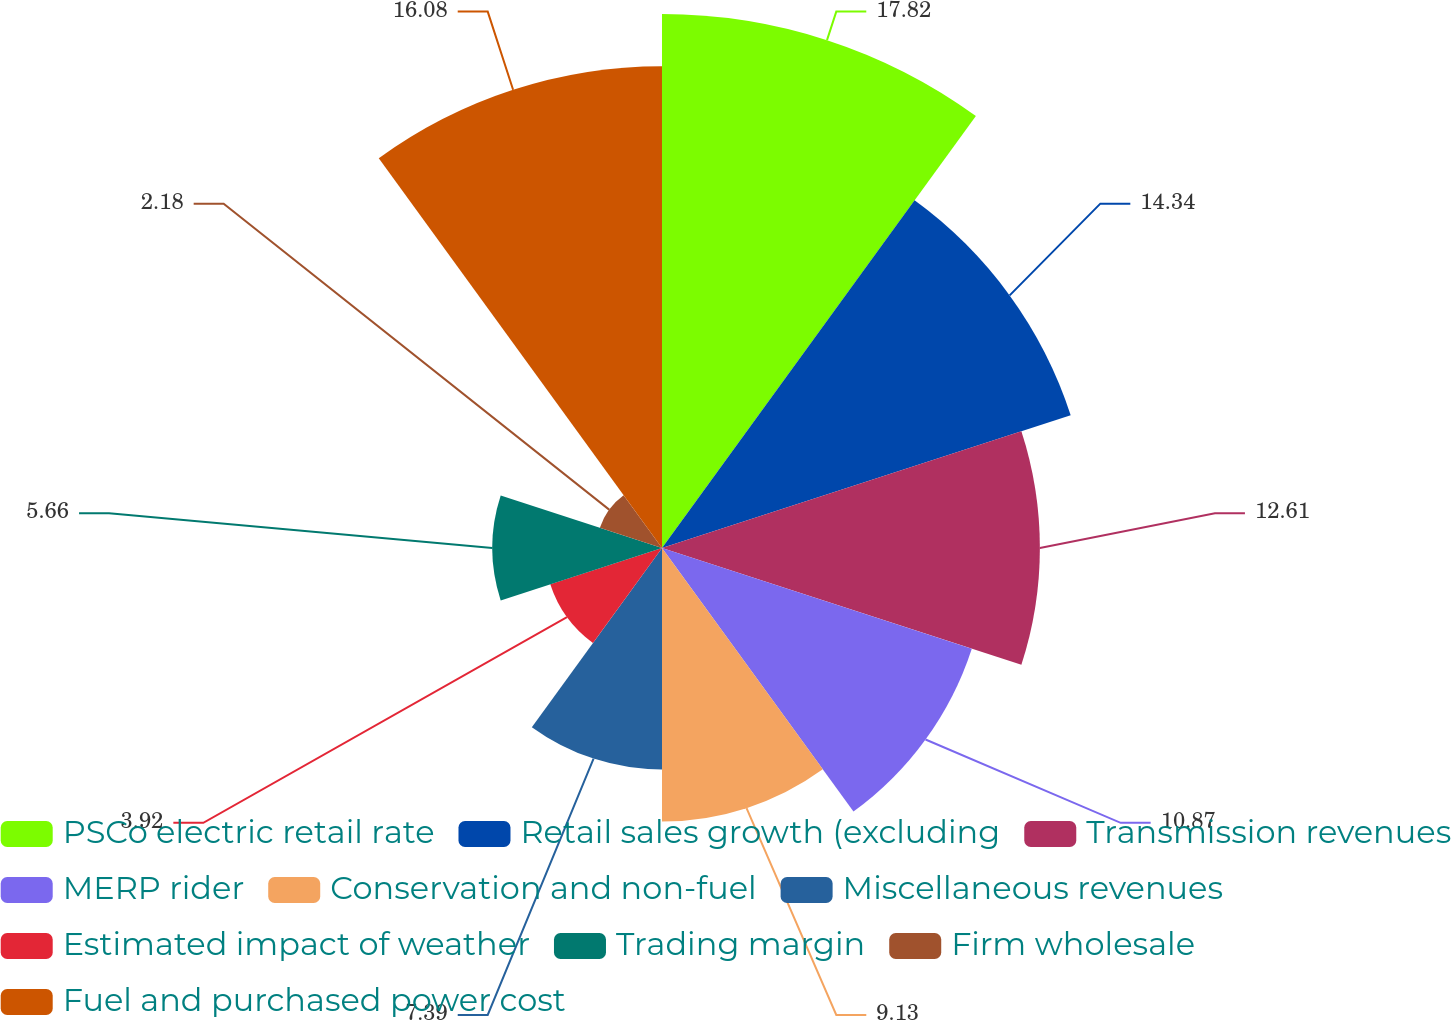Convert chart. <chart><loc_0><loc_0><loc_500><loc_500><pie_chart><fcel>PSCo electric retail rate<fcel>Retail sales growth (excluding<fcel>Transmission revenues<fcel>MERP rider<fcel>Conservation and non-fuel<fcel>Miscellaneous revenues<fcel>Estimated impact of weather<fcel>Trading margin<fcel>Firm wholesale<fcel>Fuel and purchased power cost<nl><fcel>17.82%<fcel>14.34%<fcel>12.61%<fcel>10.87%<fcel>9.13%<fcel>7.39%<fcel>3.92%<fcel>5.66%<fcel>2.18%<fcel>16.08%<nl></chart> 